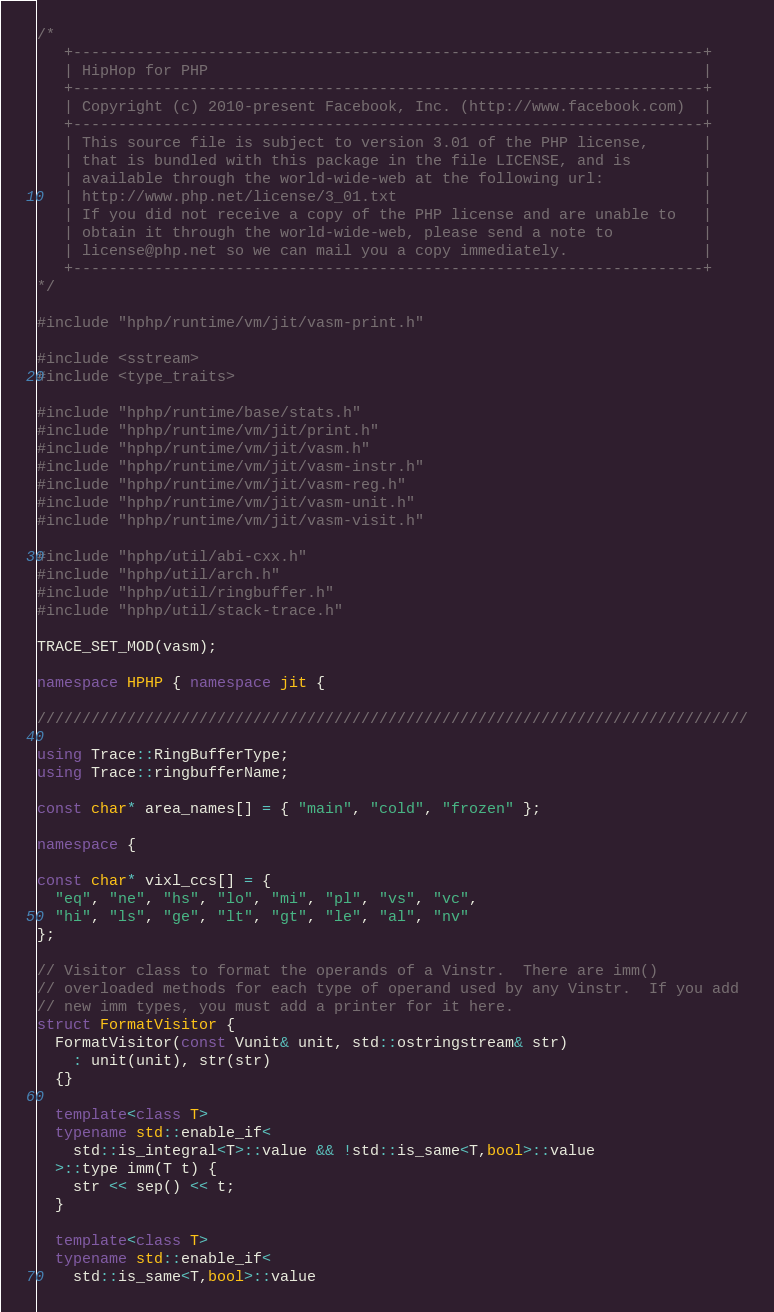<code> <loc_0><loc_0><loc_500><loc_500><_C++_>/*
   +----------------------------------------------------------------------+
   | HipHop for PHP                                                       |
   +----------------------------------------------------------------------+
   | Copyright (c) 2010-present Facebook, Inc. (http://www.facebook.com)  |
   +----------------------------------------------------------------------+
   | This source file is subject to version 3.01 of the PHP license,      |
   | that is bundled with this package in the file LICENSE, and is        |
   | available through the world-wide-web at the following url:           |
   | http://www.php.net/license/3_01.txt                                  |
   | If you did not receive a copy of the PHP license and are unable to   |
   | obtain it through the world-wide-web, please send a note to          |
   | license@php.net so we can mail you a copy immediately.               |
   +----------------------------------------------------------------------+
*/

#include "hphp/runtime/vm/jit/vasm-print.h"

#include <sstream>
#include <type_traits>

#include "hphp/runtime/base/stats.h"
#include "hphp/runtime/vm/jit/print.h"
#include "hphp/runtime/vm/jit/vasm.h"
#include "hphp/runtime/vm/jit/vasm-instr.h"
#include "hphp/runtime/vm/jit/vasm-reg.h"
#include "hphp/runtime/vm/jit/vasm-unit.h"
#include "hphp/runtime/vm/jit/vasm-visit.h"

#include "hphp/util/abi-cxx.h"
#include "hphp/util/arch.h"
#include "hphp/util/ringbuffer.h"
#include "hphp/util/stack-trace.h"

TRACE_SET_MOD(vasm);

namespace HPHP { namespace jit {

///////////////////////////////////////////////////////////////////////////////

using Trace::RingBufferType;
using Trace::ringbufferName;

const char* area_names[] = { "main", "cold", "frozen" };

namespace {

const char* vixl_ccs[] = {
  "eq", "ne", "hs", "lo", "mi", "pl", "vs", "vc",
  "hi", "ls", "ge", "lt", "gt", "le", "al", "nv"
};

// Visitor class to format the operands of a Vinstr.  There are imm()
// overloaded methods for each type of operand used by any Vinstr.  If you add
// new imm types, you must add a printer for it here.
struct FormatVisitor {
  FormatVisitor(const Vunit& unit, std::ostringstream& str)
    : unit(unit), str(str)
  {}

  template<class T>
  typename std::enable_if<
    std::is_integral<T>::value && !std::is_same<T,bool>::value
  >::type imm(T t) {
    str << sep() << t;
  }

  template<class T>
  typename std::enable_if<
    std::is_same<T,bool>::value</code> 